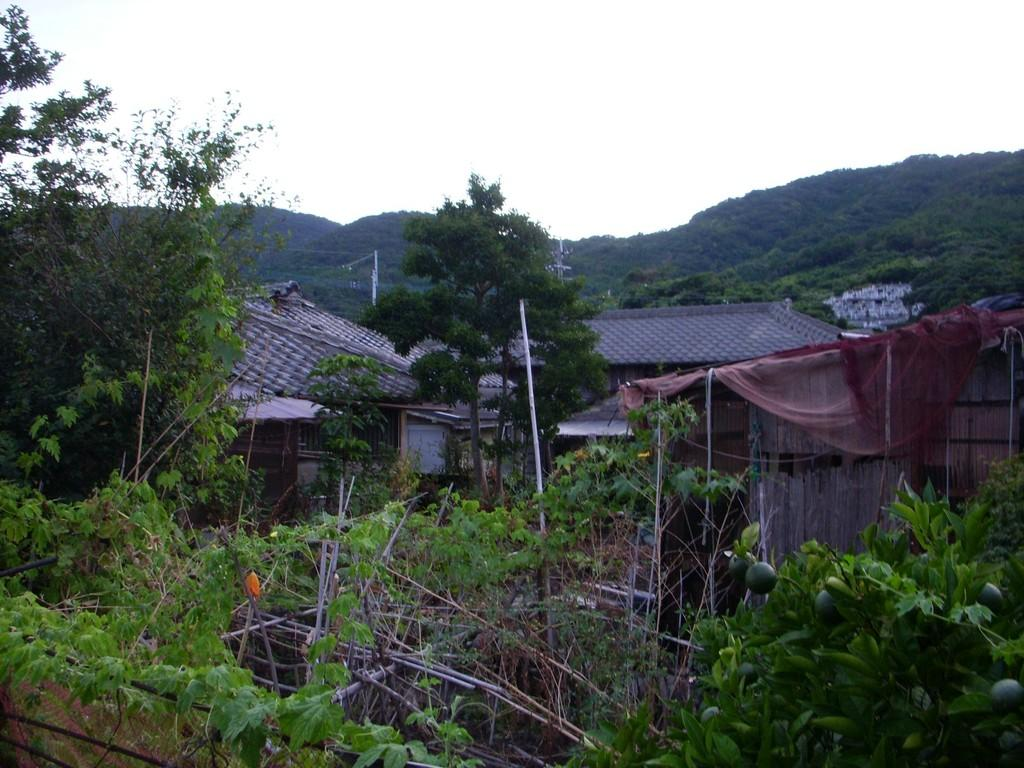What is located in the center of the image? In the center of the image, there are buildings, roofs, a wall, a curtain, trees, fruits, and a fence. What type of vegetation can be seen in the center of the image? In the center of the image, there are trees and plants. What is visible in the background of the image? In the background of the image, there is sky, clouds, a hill, and trees. How many machines are visible in the image? There are no machines present in the image. Are there any dogs visible in the image? There are no dogs present in the image. 